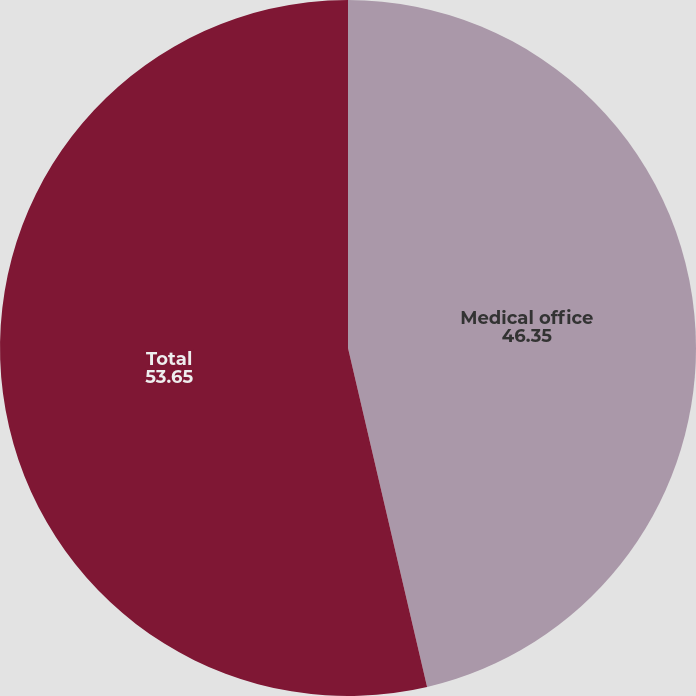<chart> <loc_0><loc_0><loc_500><loc_500><pie_chart><fcel>Medical office<fcel>Total<nl><fcel>46.35%<fcel>53.65%<nl></chart> 